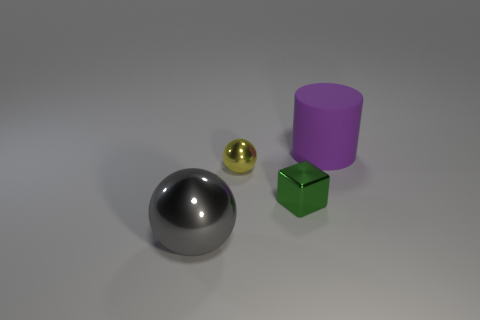Are there the same number of purple matte cylinders that are in front of the gray sphere and cylinders?
Your answer should be very brief. No. How many things are purple matte cubes or big gray balls?
Offer a terse response. 1. Is there anything else that has the same shape as the small yellow shiny object?
Your answer should be compact. Yes. There is a large thing behind the big thing in front of the large matte object; what shape is it?
Keep it short and to the point. Cylinder. What shape is the yellow object that is made of the same material as the gray ball?
Your answer should be very brief. Sphere. What is the size of the sphere that is in front of the tiny thing that is in front of the yellow metallic object?
Your answer should be very brief. Large. The big purple object has what shape?
Offer a terse response. Cylinder. How many large objects are either blue rubber cylinders or rubber things?
Offer a very short reply. 1. What size is the other object that is the same shape as the large gray thing?
Make the answer very short. Small. What number of big objects are right of the yellow shiny thing and on the left side of the big purple matte cylinder?
Provide a short and direct response. 0. 